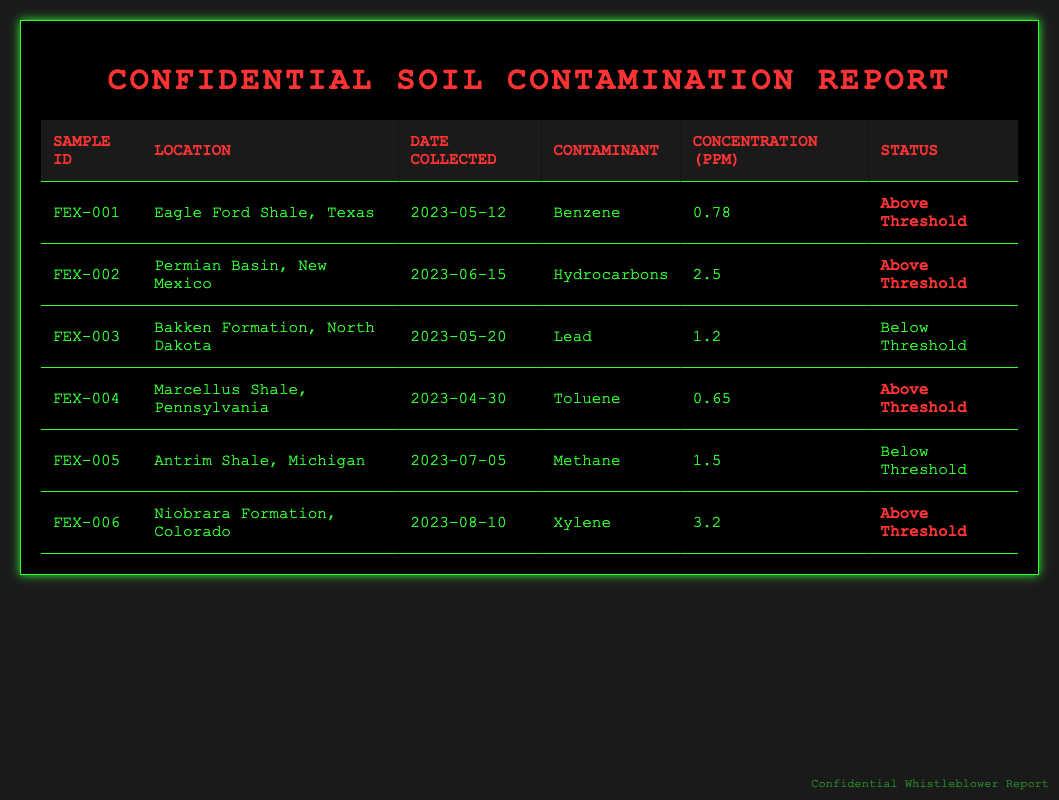What is the concentration of Benzene in Sample FEX-001? The table lists the concentration of Benzene in Sample FEX-001 under the "Concentration (ppm)" column, showing it as 0.78 ppm.
Answer: 0.78 ppm Which location has the highest concentration of contaminants? Looking at the "Concentration (ppm)" column, the highest value is 3.2 ppm from the Niobrara Formation, Colorado (Sample FEX-006).
Answer: Niobrara Formation, Colorado How many samples are classified as "Below Threshold"? There are two samples classified as "Below Threshold," namely FEX-003 (Lead, 1.2 ppm) and FEX-005 (Methane, 1.5 ppm).
Answer: 2 Is the concentration of Toluene in Sample FEX-004 above or below the threshold? In the table, the status for Toluene in Sample FEX-004 is marked as "Above Threshold," indicating it exceeds the allowable concentration.
Answer: Above Threshold What is the average concentration of contaminants in the samples that are above threshold? For the samples above threshold (FEX-001, FEX-002, FEX-004, and FEX-006), their concentrations are 0.78, 2.5, 0.65, and 3.2 ppm, respectively. The average is (0.78 + 2.5 + 0.65 + 3.2) / 4 = 1.7825 ppm.
Answer: 1.7825 ppm How many different contaminants were reported in the samples? The table lists five different contaminants: Benzene, Hydrocarbons, Lead, Toluene, and Xylene. Thus, there are five unique contaminants reported.
Answer: 5 Which sample was collected most recently, and what contaminant did it test for? Sample FEX-006, collected on 2023-08-10, is the most recent and tested for Xylene.
Answer: Sample FEX-006, Xylene Is there any sample from the Marcellus Shale that has a concentration below the threshold? In the table, the Marcellus Shale (FEX-004) has a concentration of Toluene listed as "Above Threshold," indicating there are no below-threshold samples from that location.
Answer: No What is the difference in concentration between the highest and lowest readings from the table? The highest concentration is 3.2 ppm (Xylene, FEX-006) and the lowest is 0.65 ppm (Toluene, FEX-004). The difference is calculated as 3.2 - 0.65 = 2.55 ppm.
Answer: 2.55 ppm 